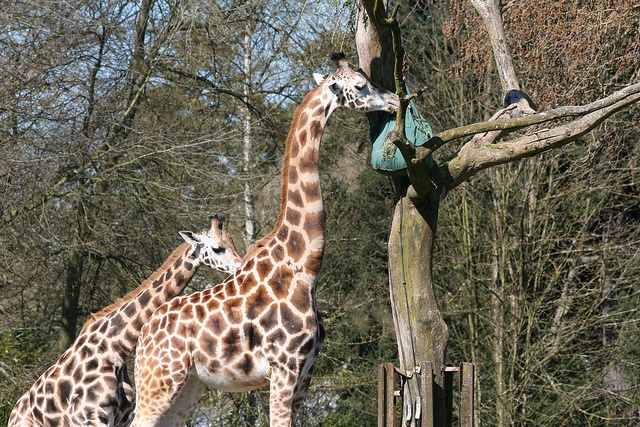Describe the objects in this image and their specific colors. I can see giraffe in gray, white, and tan tones, giraffe in gray, white, and tan tones, and handbag in gray, darkgray, black, and teal tones in this image. 